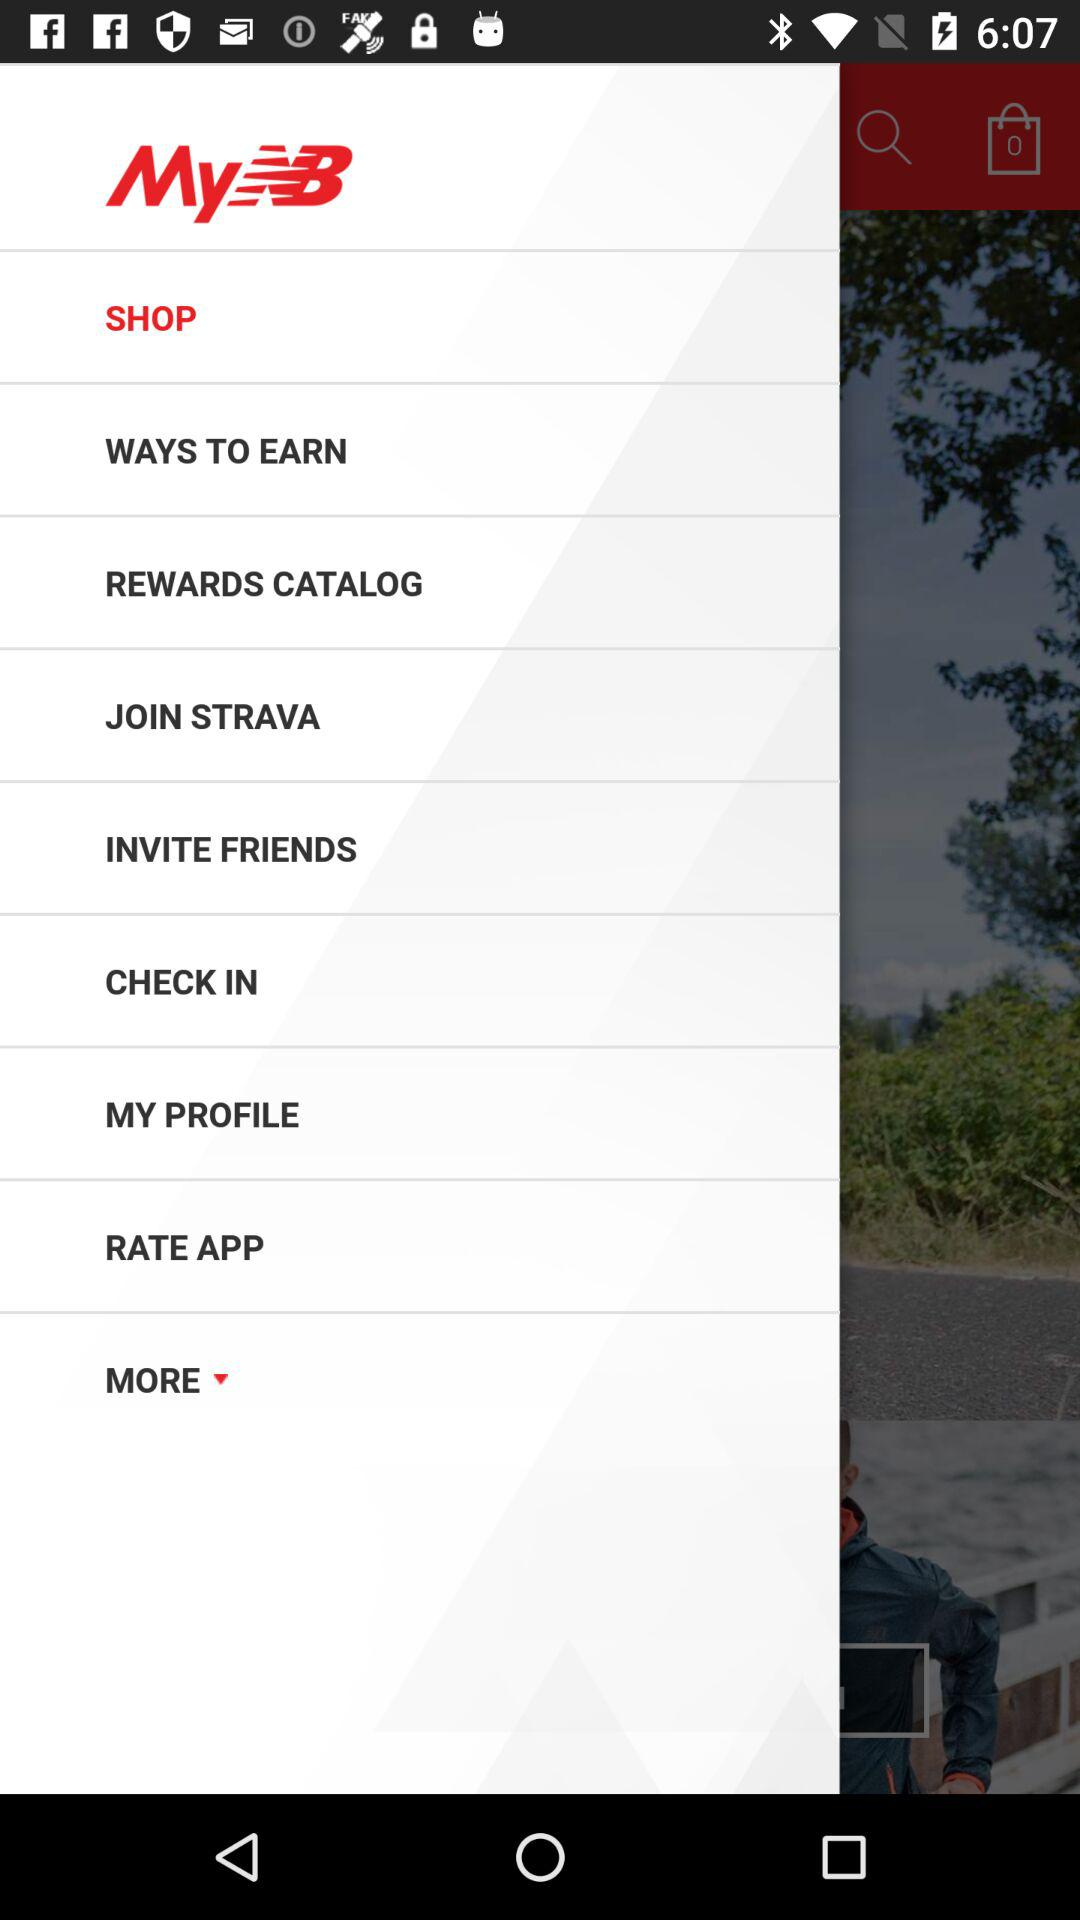How many shopping bags are there on the screen?
Answer the question using a single word or phrase. 1 